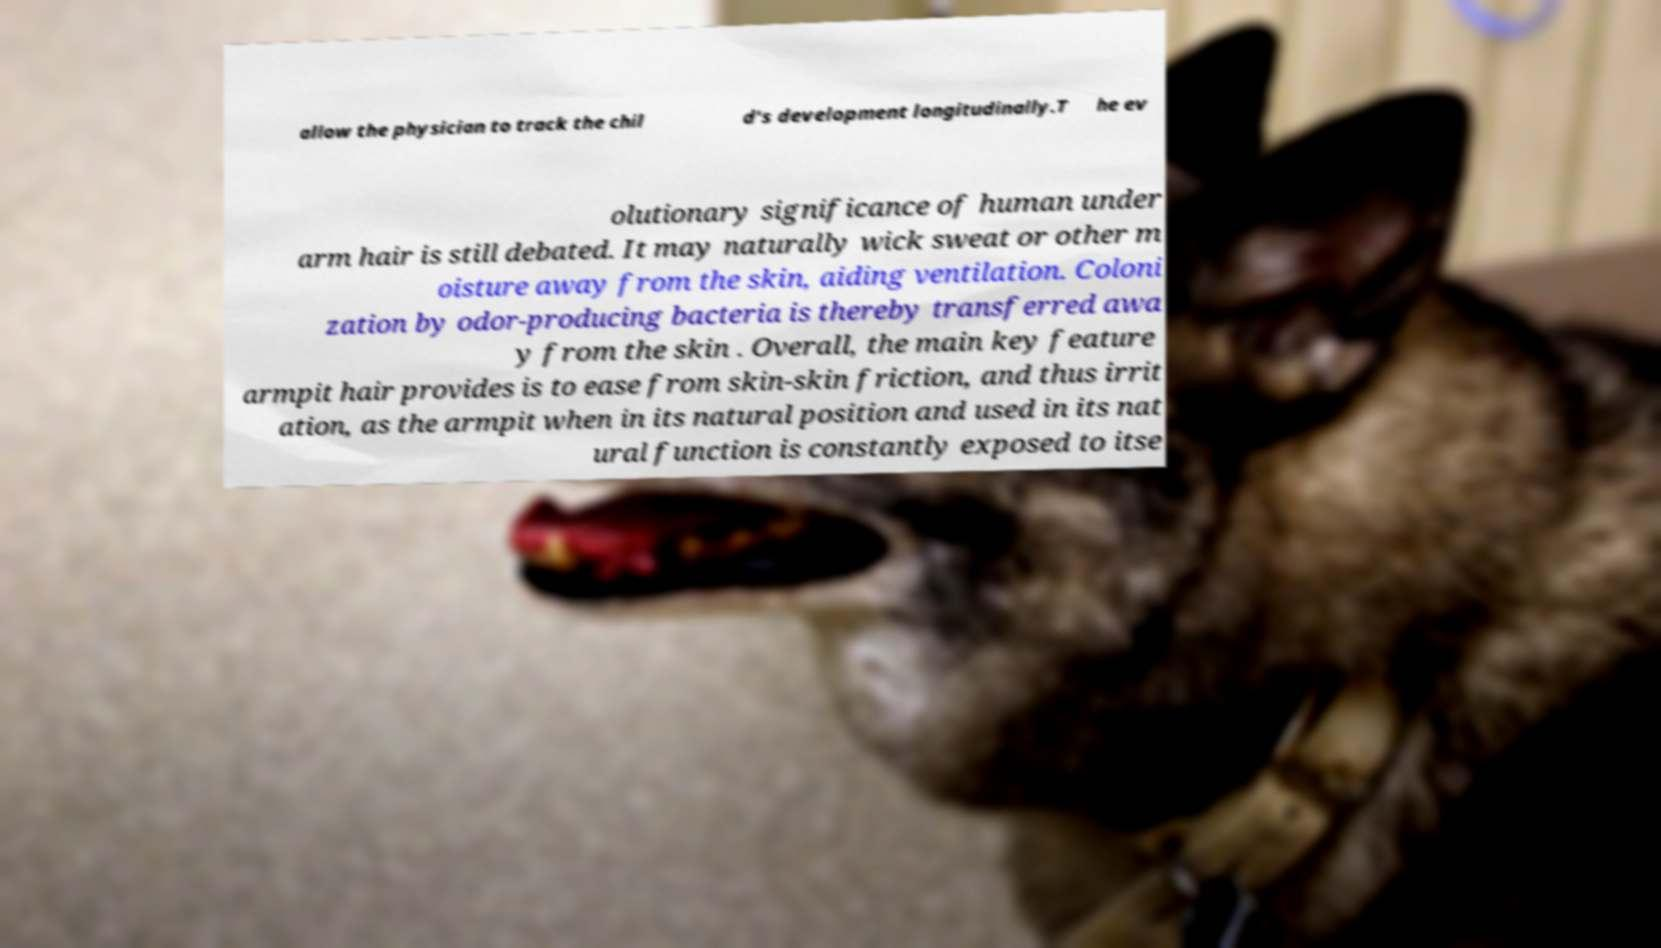Please read and relay the text visible in this image. What does it say? allow the physician to track the chil d's development longitudinally.T he ev olutionary significance of human under arm hair is still debated. It may naturally wick sweat or other m oisture away from the skin, aiding ventilation. Coloni zation by odor-producing bacteria is thereby transferred awa y from the skin . Overall, the main key feature armpit hair provides is to ease from skin-skin friction, and thus irrit ation, as the armpit when in its natural position and used in its nat ural function is constantly exposed to itse 